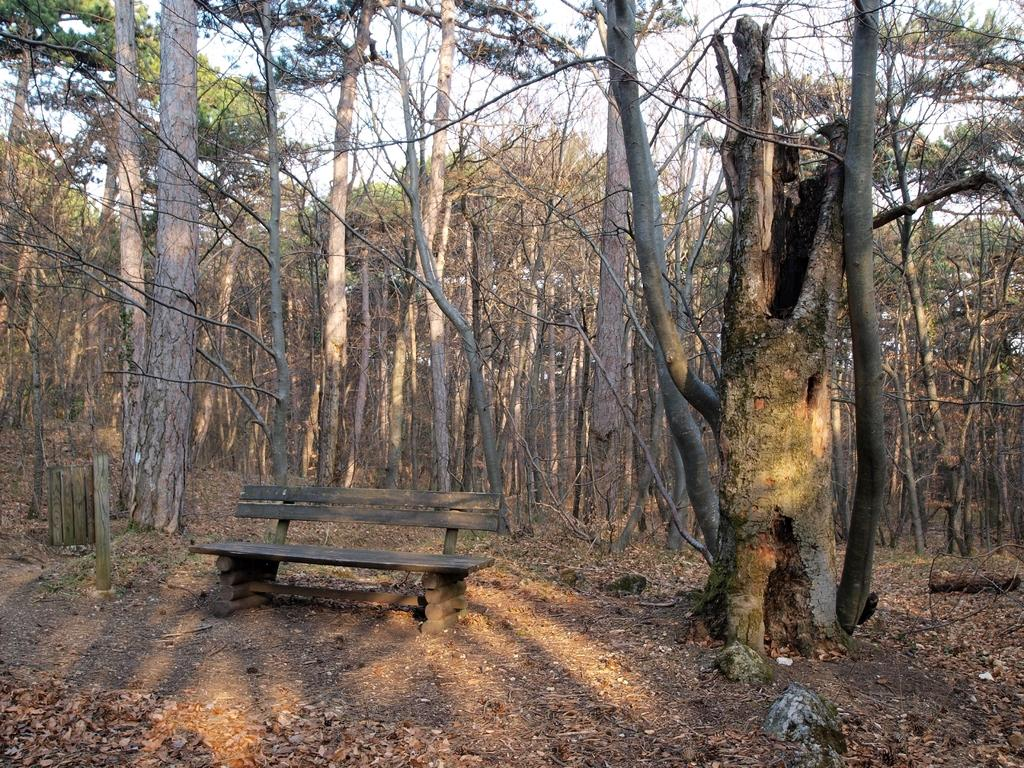What is located in the center of the image? There is a bench in the center of the image. What can be seen in the background of the image? There are trees and the sky visible in the background of the image. What type of vacation destination is depicted in the image? There is no specific vacation destination depicted in the image; it simply features a bench and trees in the background. What kind of jewel can be seen hanging from the trees in the image? There are no jewels present in the image; it only features a bench and trees in the background. 